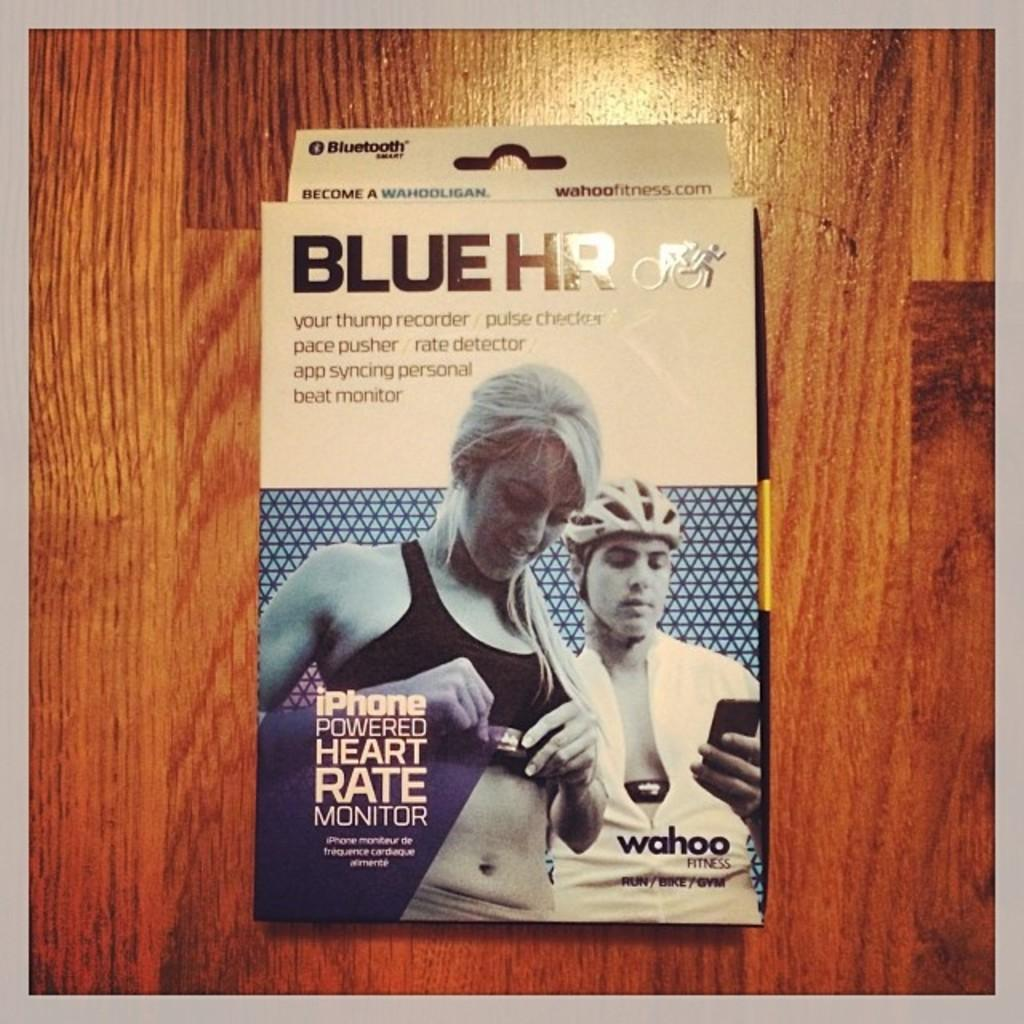<image>
Summarize the visual content of the image. a box of Blue HR to be used during sports 